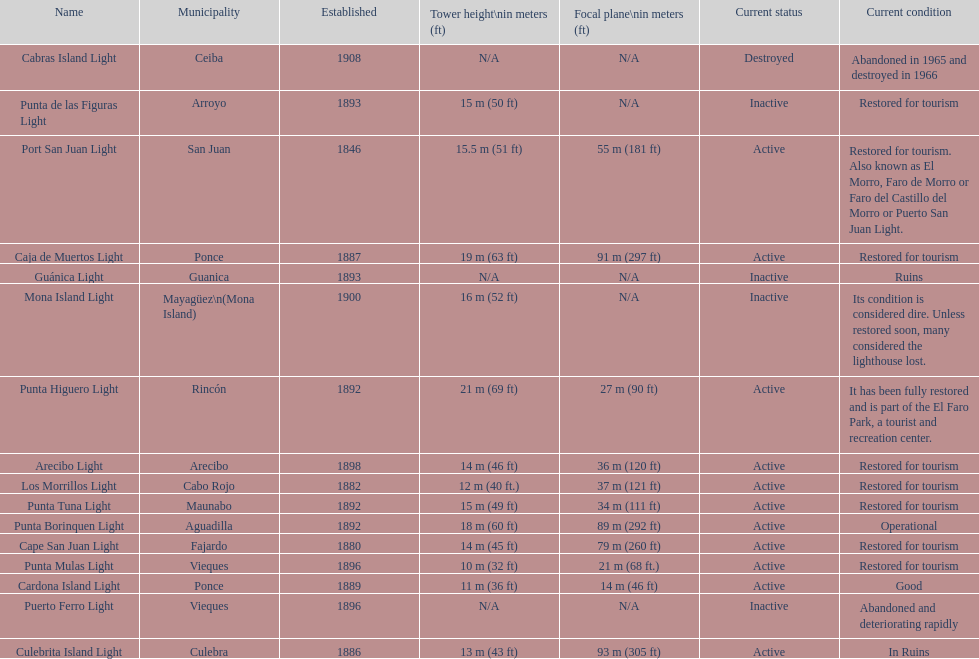What is the largest tower Punta Higuero Light. 